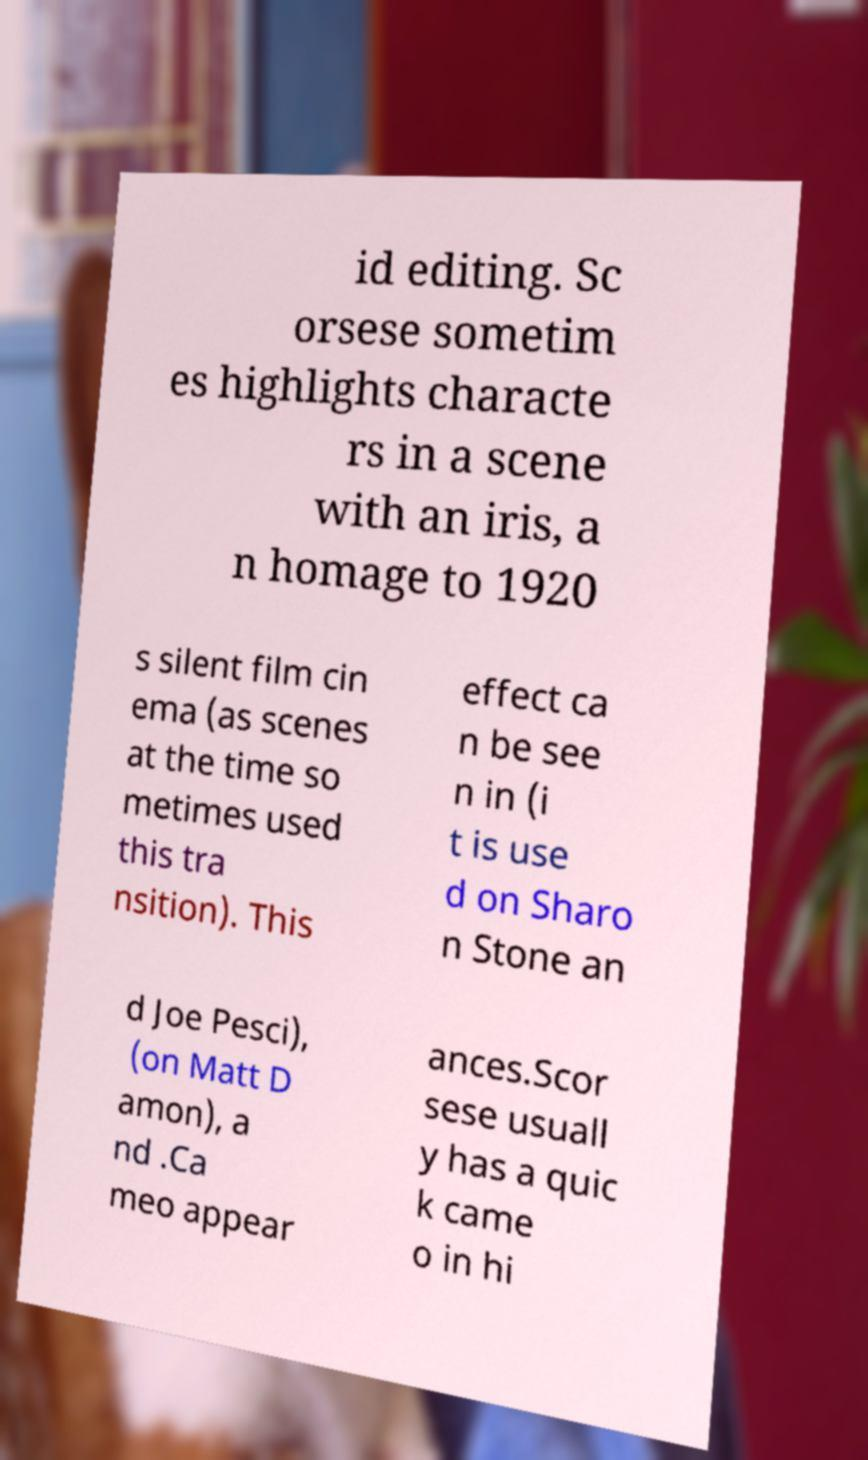Can you read and provide the text displayed in the image?This photo seems to have some interesting text. Can you extract and type it out for me? id editing. Sc orsese sometim es highlights characte rs in a scene with an iris, a n homage to 1920 s silent film cin ema (as scenes at the time so metimes used this tra nsition). This effect ca n be see n in (i t is use d on Sharo n Stone an d Joe Pesci), (on Matt D amon), a nd .Ca meo appear ances.Scor sese usuall y has a quic k came o in hi 